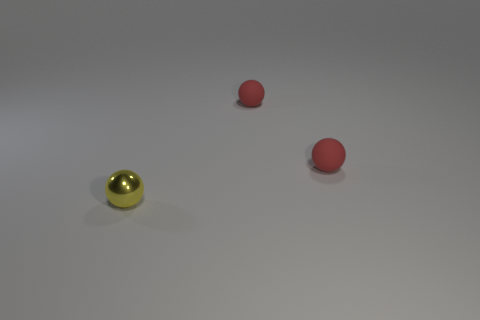What number of other things are the same size as the metallic ball?
Keep it short and to the point. 2. How many other things are the same shape as the yellow metallic object?
Ensure brevity in your answer.  2. Are there any green things made of the same material as the tiny yellow sphere?
Your answer should be compact. No. What number of small brown metallic objects are there?
Offer a very short reply. 0. What number of things are either tiny things that are behind the yellow sphere or small balls that are on the right side of the shiny sphere?
Keep it short and to the point. 2. Is there a red sphere that has the same size as the yellow thing?
Ensure brevity in your answer.  Yes. What number of rubber objects are red spheres or tiny spheres?
Ensure brevity in your answer.  2. Is there any other thing that is the same shape as the tiny yellow metallic object?
Offer a very short reply. Yes. How many other things are the same color as the metal thing?
Make the answer very short. 0. Are there any other things that have the same material as the yellow object?
Give a very brief answer. No. 